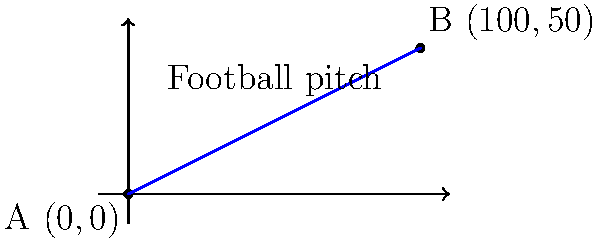On a coordinate system overlaid on the PS Bangka Setara home pitch, player A is at position $(0,0)$ and player B is at position $(100,50)$. Calculate the distance between these two players on the pitch, rounded to the nearest meter. To find the distance between two points on a coordinate plane, we can use the distance formula:

$$d = \sqrt{(x_2-x_1)^2 + (y_2-y_1)^2}$$

Where $(x_1,y_1)$ are the coordinates of point A and $(x_2,y_2)$ are the coordinates of point B.

Given:
- Point A: $(0,0)$
- Point B: $(100,50)$

Let's substitute these values into the formula:

$$\begin{align}
d &= \sqrt{(100-0)^2 + (50-0)^2} \\
&= \sqrt{100^2 + 50^2} \\
&= \sqrt{10000 + 2500} \\
&= \sqrt{12500} \\
&\approx 111.80339887 \text{ meters}
\end{align}$$

Rounding to the nearest meter:

$$d \approx 112 \text{ meters}$$

Therefore, the distance between the two players on the PS Bangka Setara pitch is approximately 112 meters.
Answer: 112 meters 